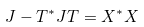Convert formula to latex. <formula><loc_0><loc_0><loc_500><loc_500>J - T ^ { * } J T = X ^ { * } X</formula> 